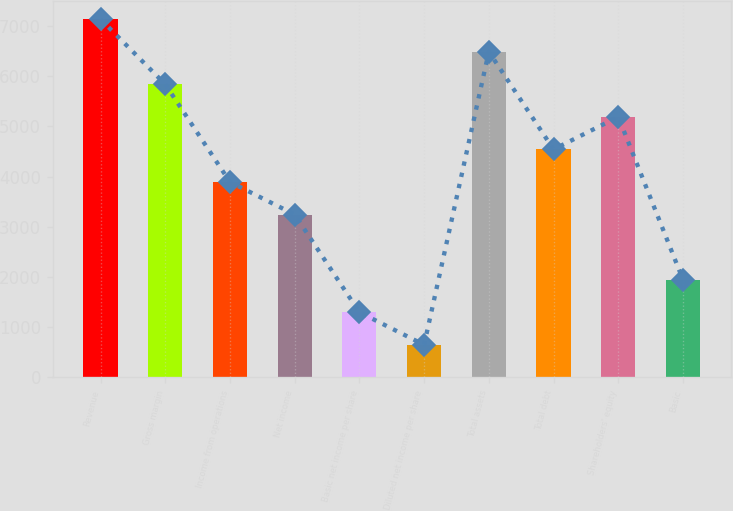Convert chart to OTSL. <chart><loc_0><loc_0><loc_500><loc_500><bar_chart><fcel>Revenue<fcel>Gross margin<fcel>Income from operations<fcel>Net income<fcel>Basic net income per share<fcel>Diluted net income per share<fcel>Total assets<fcel>Total debt<fcel>Shareholders' equity<fcel>Basic<nl><fcel>7134.54<fcel>5837.48<fcel>3891.89<fcel>3243.36<fcel>1297.77<fcel>649.24<fcel>6486.01<fcel>4540.42<fcel>5188.95<fcel>1946.3<nl></chart> 